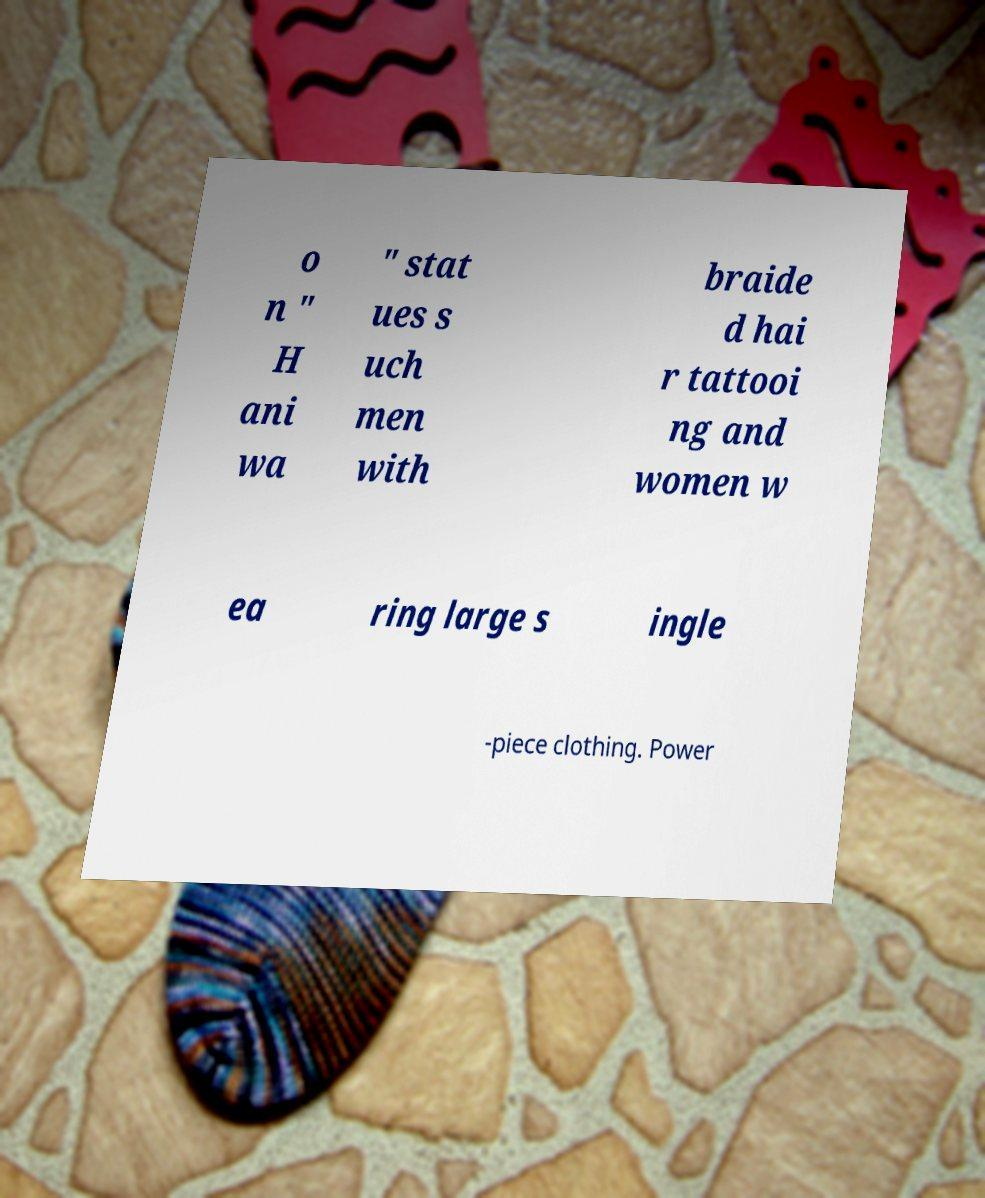Could you assist in decoding the text presented in this image and type it out clearly? o n " H ani wa " stat ues s uch men with braide d hai r tattooi ng and women w ea ring large s ingle -piece clothing. Power 